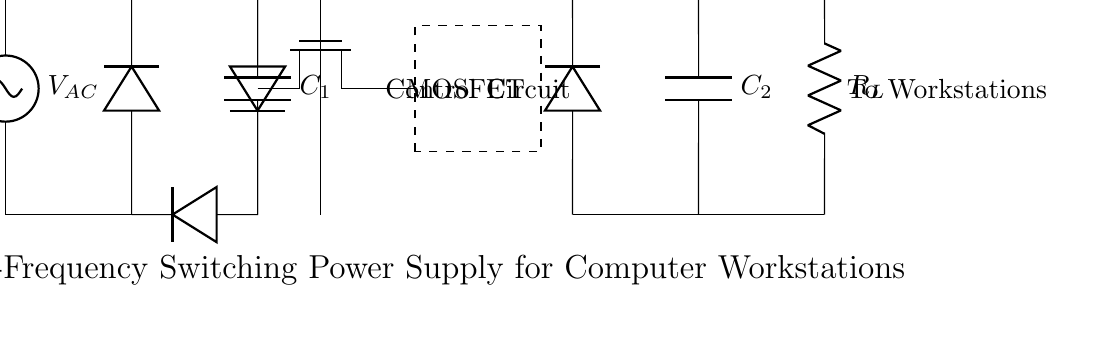What is the input voltage to the circuit? The input voltage is denoted as V_AC on the left side of the circuit diagram, which is typically the alternating current supplied to the system.
Answer: V_AC What component rectifies the alternating current? The component that rectifies the alternating current is the bridge rectifier, which is represented by four diodes configured in a bridge formation.
Answer: Bridge Rectifier What is the purpose of capacitor C_1 in the circuit? Capacitor C_1 smooths the output of the bridge rectifier by storing charge and releasing it to reduce voltage fluctuations, effectively filtering the rectified output.
Answer: Smoothing What does the transformer core do in this circuit? The transformer core here indicates that it steps up or steps down voltage and provides isolation between the primary and secondary circuits depending on the design, using magnetic induction.
Answer: Voltage Transformation What is the purpose of the control circuit? The control circuit regulates the operation of the MOSFET switch, managing the timing and switching frequency to efficiently control the power output to the workstations.
Answer: Regulation How does the output voltage compare to the input voltage? The output voltage is implied to be different from the AC input voltage due to the processing by the transformer and rectification stages, typically providing a lower or modified voltage suitable for the workstations.
Answer: Modified What is the load resistance denoted as R_L connected to? Load resistance R_L is connected to the output section of the circuit, representing the load that the power supply needs to drive, which in this case is the computer workstations.
Answer: Workstations 